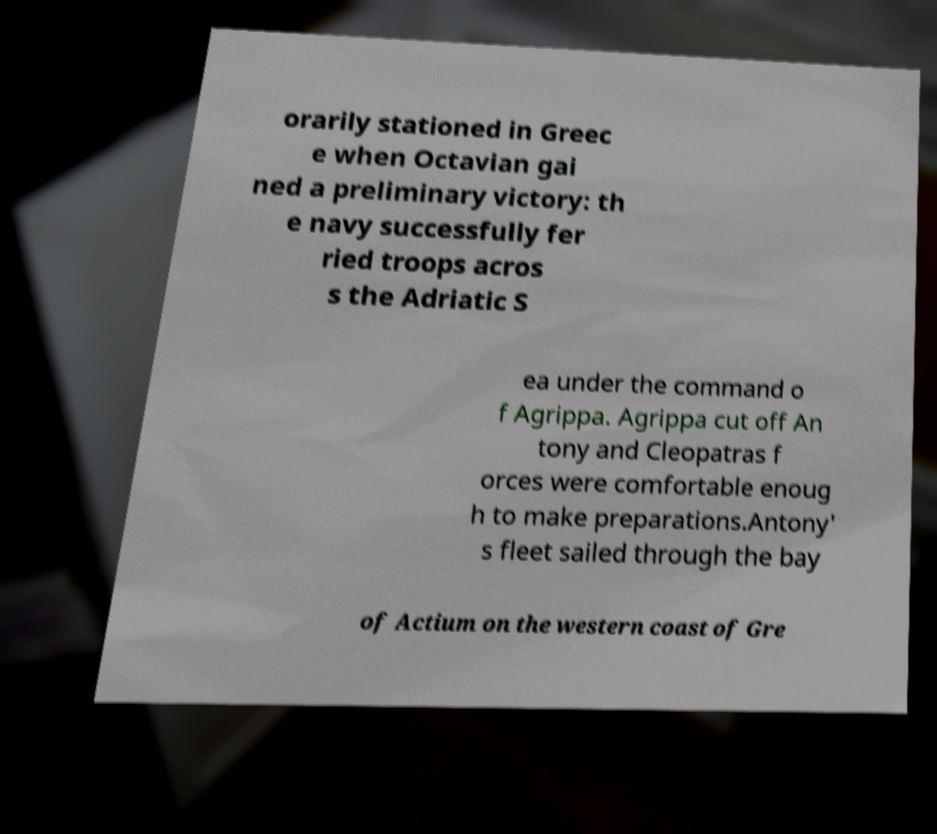I need the written content from this picture converted into text. Can you do that? orarily stationed in Greec e when Octavian gai ned a preliminary victory: th e navy successfully fer ried troops acros s the Adriatic S ea under the command o f Agrippa. Agrippa cut off An tony and Cleopatras f orces were comfortable enoug h to make preparations.Antony' s fleet sailed through the bay of Actium on the western coast of Gre 